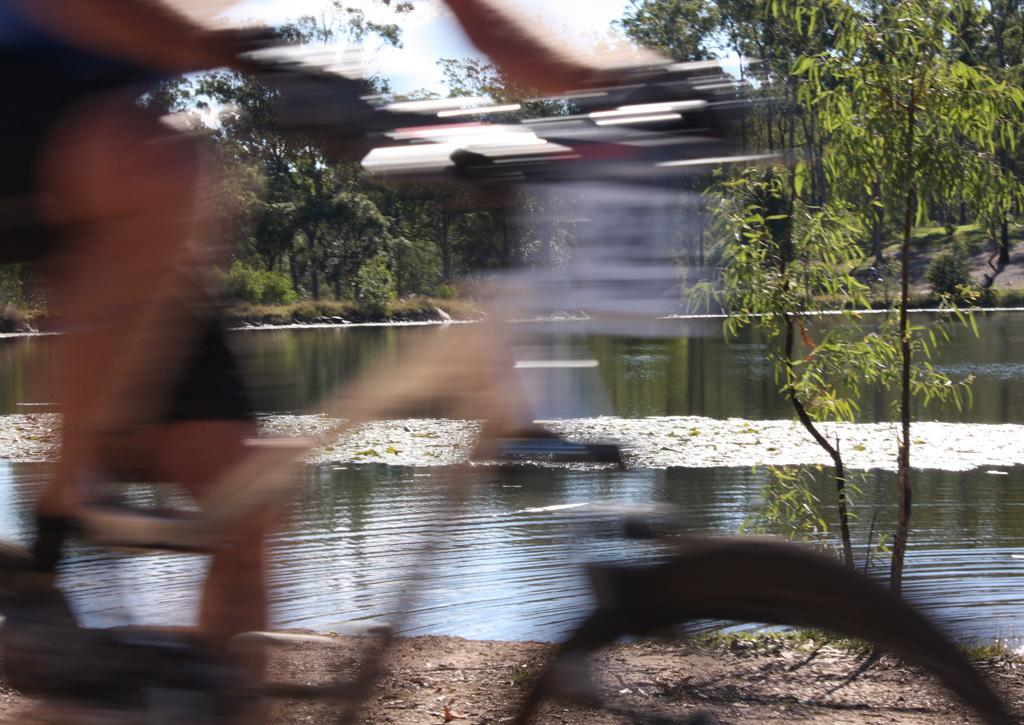What is the main subject of the image? There is a person riding a bicycle in the image. How is the bicycle depicted in the image? The bicycle is blurred. What can be seen in the background of the image? There is a lake and trees in the background of the image. What is the condition of the sky in the image? The sky is clear in the image. What type of pest can be seen crawling on the person's leg in the image? There is no pest visible on the person's leg in the image. What material is the bicycle made of, as seen in the image? The image does not provide enough detail to determine the material of the bicycle. 